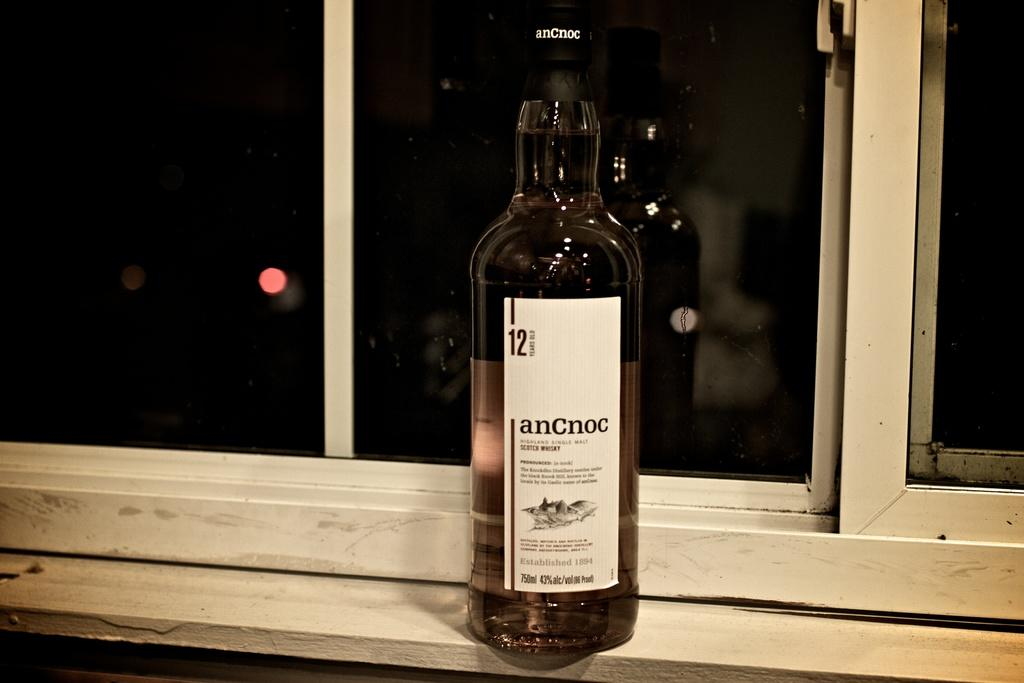<image>
Describe the image concisely. the word anCnoc that is on a wine bottle 